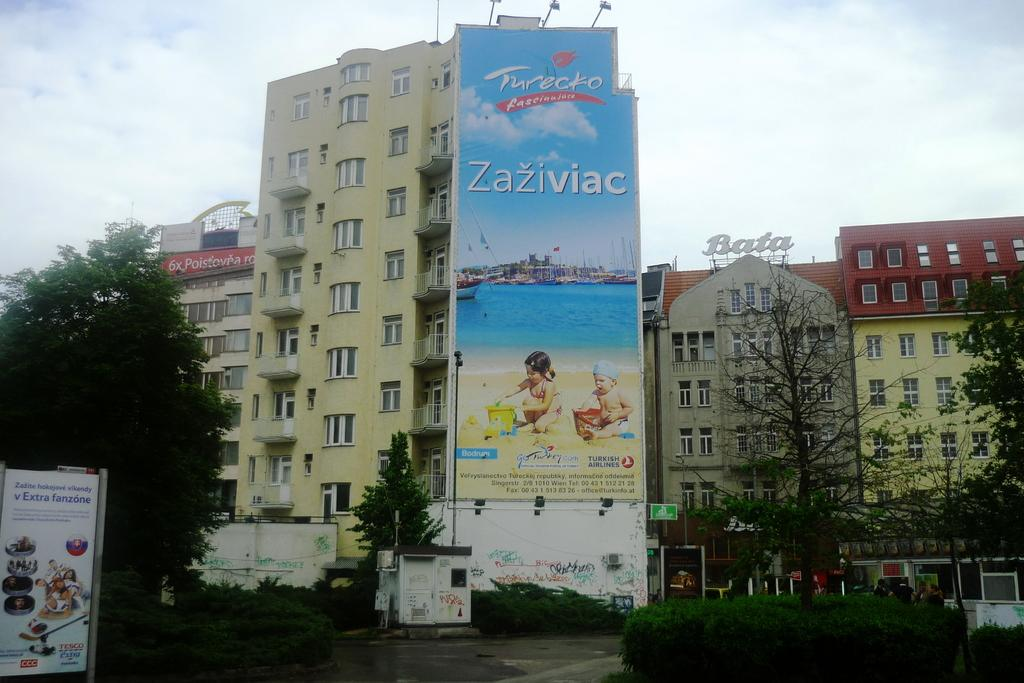Provide a one-sentence caption for the provided image. A large billboard on the side of  a high-rise building on which is written Zaziviac. 